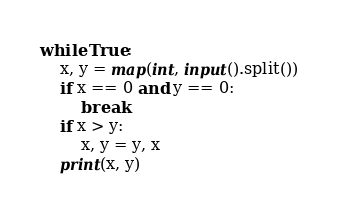Convert code to text. <code><loc_0><loc_0><loc_500><loc_500><_Python_>while True:
    x, y = map(int, input().split())
    if x == 0 and y == 0:
        break
    if x > y:
        x, y = y, x
    print(x, y)


</code> 